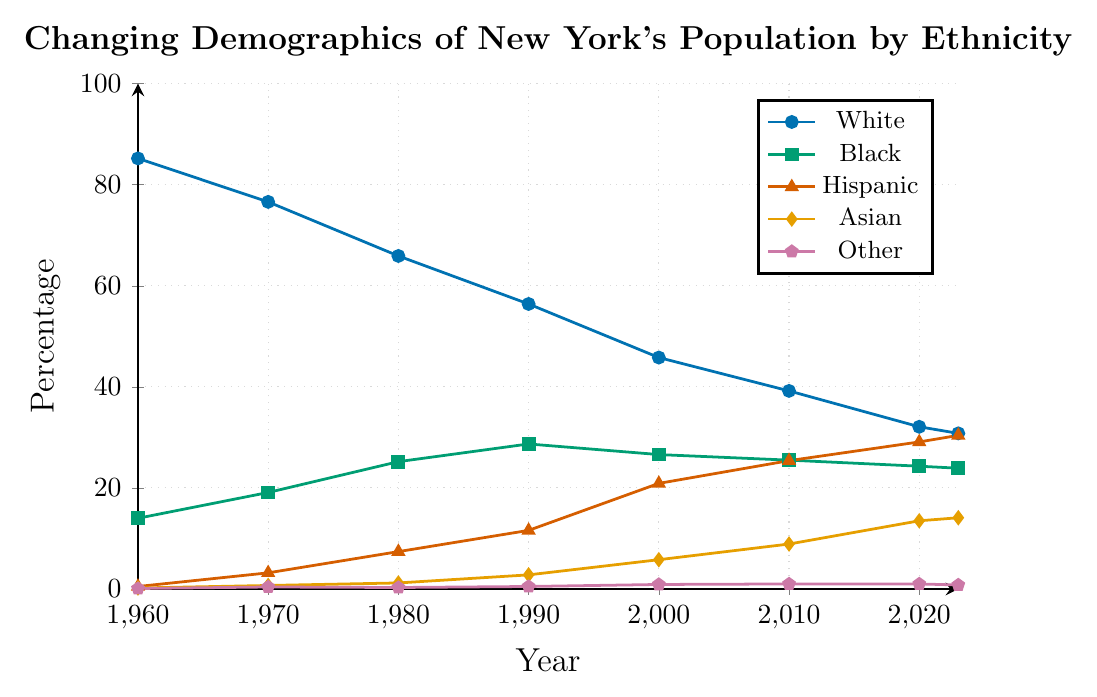Which ethnic group had the highest percentage in 1960? The figure shows that the White group has the highest percentage in 1960, represented by the blue line starting at 85.2 on the y-axis.
Answer: White How has the percentage of the Hispanic population changed from 1960 to 2023? The percentage of the Hispanic population increased from 0.5 in 1960 to 30.4 in 2023 according to the red line.
Answer: Increased Which ethnic group had the least change in percentage points from 1960 to 2023? The "Other" category shows minimal change, starting at 0.1 in 1960 and only reaching 0.8 in 2023, based on the purple line.
Answer: Other In 2000, which ethnic group had the second-highest percentage? The figure depicts that the White group had the highest percentage in 2000 (45.8%), and the Black group had the second-highest percentage at 26.6%, shown in green.
Answer: Black Which years had a higher percentage of the Asian population than Black population after 2000? Checking the graph reveals that there were no years after 2000 where the Asian percentage eclipsed the Black percentage, with the green line consistently higher than the orange line.
Answer: None By how many percentage points did the White population decline from 1960 to 2023? The percentage of the White population dropped from 85.2 in 1960 to 30.8 in 2023, resulting in a decline of 54.4 percentage points (85.2 - 30.8).
Answer: 54.4 In which year did the percentage of the Hispanic population surpass that of the Black population? The red line for Hispanics crosses above the green line for Blacks between 2010 and 2020. By 2020, the Hispanic population is higher, confirming the crossover happened in this decade.
Answer: 2020 Which ethnic group showed the most consistent growth from 1960 to 2023? The Hispanic group, represented by the red line, shows a steady and consistent increase from 0.5 in 1960 to 30.4 in 2023.
Answer: Hispanic What was the total percentage of all non-White populations in 2010? Adding the percentages for Black (25.5), Hispanic (25.4), Asian (8.9), and Other (1.0) in 2010: (25.5 + 25.4 + 8.9 + 1.0) = 60.8%.
Answer: 60.8 How did the percentage of the Asian population in 1990 compare to that in 2023? The percentage of the Asian population increased from 2.8 in 1990 to 14.1 in 2023 as indicated by the orange line.
Answer: Increased 